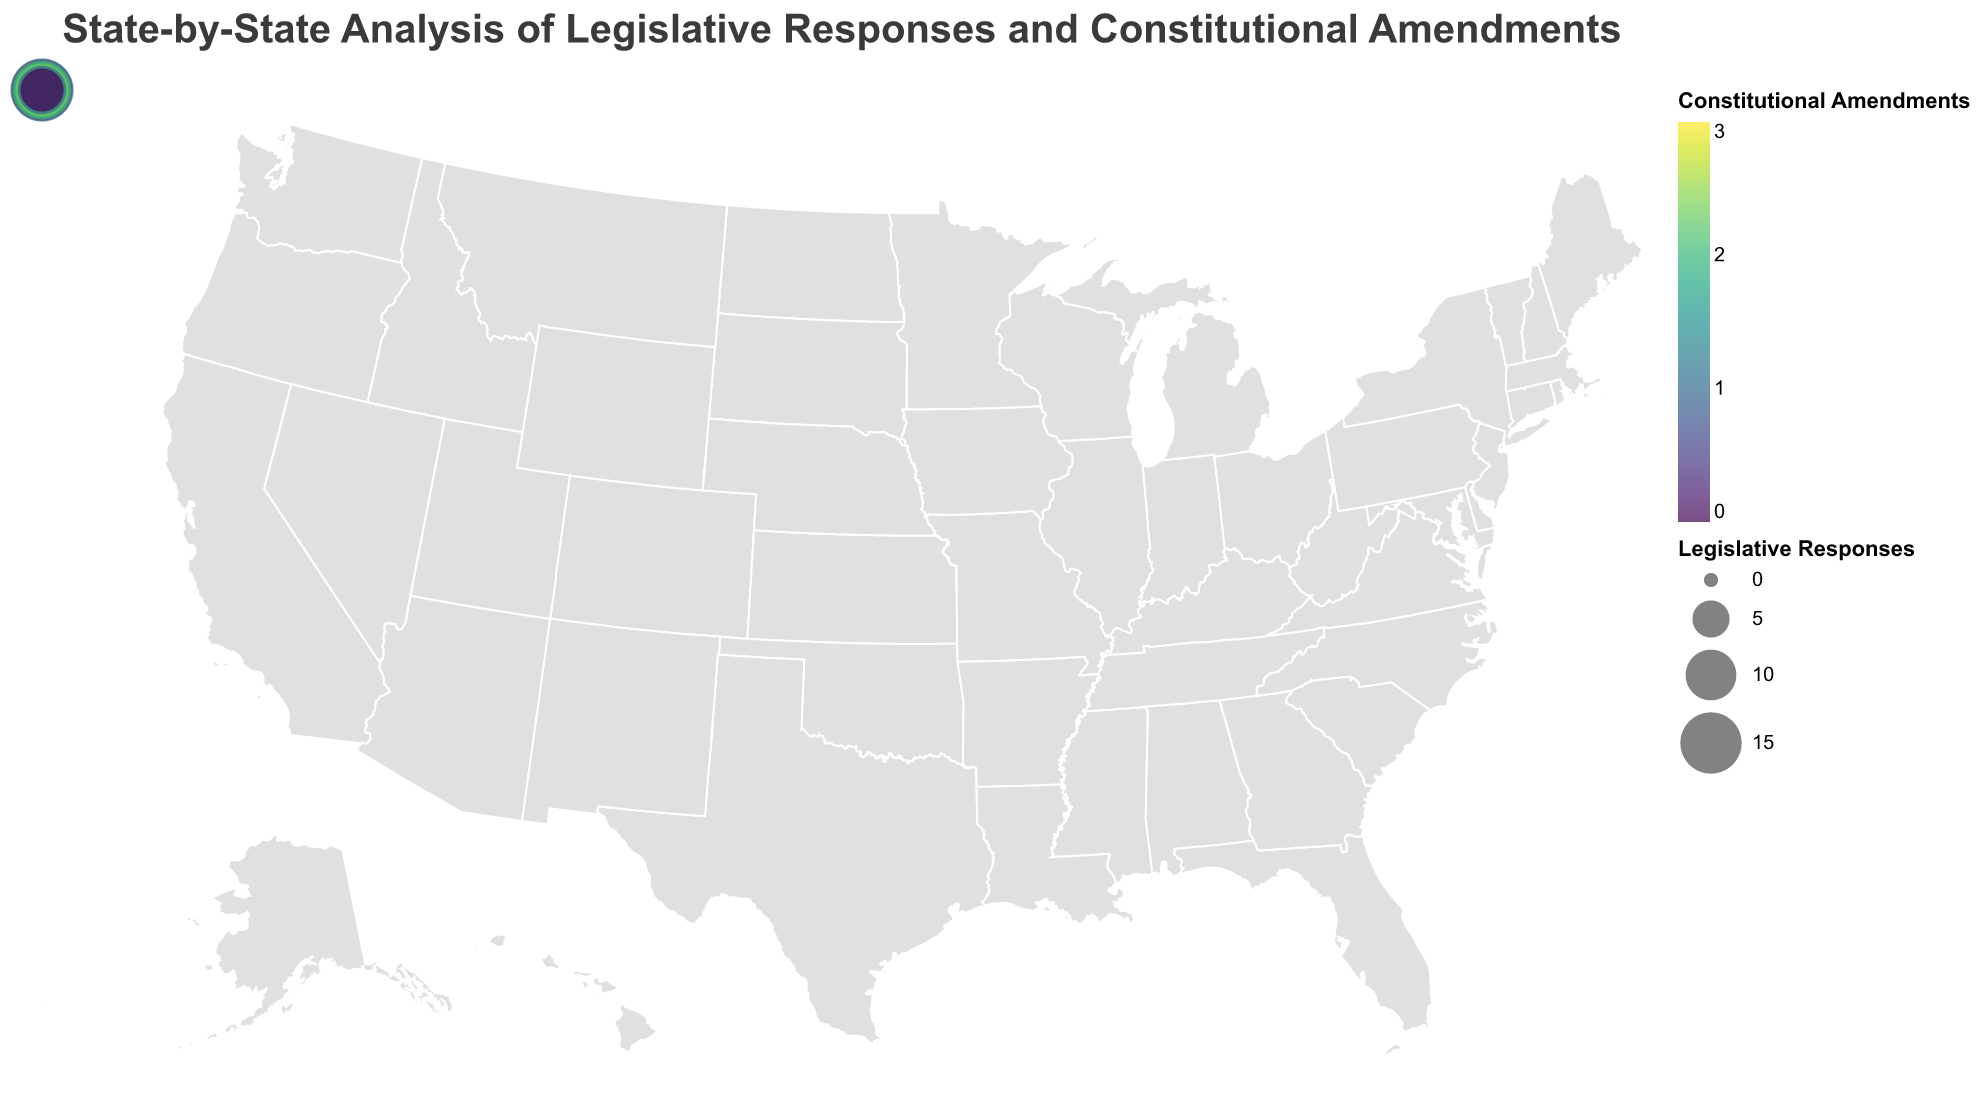What is the title of the figure? The title is usually displayed prominently at the top of the figure. It provides a summary of what the figure is about. In this case, the title would be observed directly at the top of the geographic plot.
Answer: State-by-State Analysis of Legislative Responses and Constitutional Amendments Which state has the highest number of legislative responses? By examining the sizes of the circles on the map, you can identify the largest circle, which corresponds to the state with the highest number of legislative responses. In this case, Arizona has the highest number of legislative responses with 16.
Answer: Arizona How many constitutional amendments are there in Virginia? By hovering over or identifying the circle located in Virginia, you can read the tooltip or use the color scale to determine the number of constitutional amendments. Virginia has 2 constitutional amendments.
Answer: 2 What are the states with the lowest number of legislative responses? To determine this, look for the smallest circles on the map. Massachusetts and Washington both have the lowest number of legislative responses, which is 4 and 5, respectively.
Answer: Massachusetts; Washington Compare the number of legislative responses between California and Texas. Which state has more? Locate the circles representing California and Texas, and compare their sizes. California has 12 legislative responses, while Texas has 8. Therefore, California has more legislative responses.
Answer: California How does the number of constitutional amendments in Georgia compare with that in South Carolina? By identifying the circles for Georgia and South Carolina, use the tooltip or the color intensity (represented by the color scale). Georgia has 3 constitutional amendments while South Carolina also has 3.
Answer: Georgia and South Carolina have the same number of constitutional amendments What is the total number of legislative responses for states with 2 constitutional amendments? Identify states with 2 constitutional amendments (Texas, Ohio, Virginia, Tennessee, Wisconsin, Alabama) and then sum their legislative responses: Texas (8), Ohio (11), Virginia (13), Tennessee (12), Wisconsin (9), Alabama (13). Total = 8 + 11 + 13 + 12 + 9 + 13 = 66.
Answer: 66 Which states have no constitutional amendments? States with no constitutional amendments have circles with the lightest color. These are Florida, Illinois, Michigan, Washington, Massachusetts, Maryland, and Kentucky.
Answer: Florida; Illinois; Michigan; Washington; Massachusetts; Maryland; Kentucky What is the average number of legislative responses across all states? Sum the legislative responses for all states and divide by the number of states. The sum is (12 + 8 + 15 + 10 + 7 + 9 + 11 + 14 + 6 + 8 + 13 + 5 + 16 + 4 + 12 + 7 + 10 + 6 + 9 + 8 + 5 + 11 + 13 + 9 + 7) = 239. There are 25 states, so the average is 239 / 25 = 9.56.
Answer: 9.56 Which state has exactly 11 legislative responses? By examining the tooltip or referencing the size of each circle, you can identify Ohio and South Carolina, both of which have 11 legislative responses.
Answer: Ohio; South Carolina 